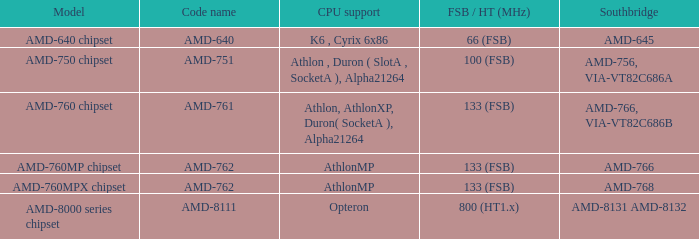Could you parse the entire table? {'header': ['Model', 'Code name', 'CPU support', 'FSB / HT (MHz)', 'Southbridge'], 'rows': [['AMD-640 chipset', 'AMD-640', 'K6 , Cyrix 6x86', '66 (FSB)', 'AMD-645'], ['AMD-750 chipset', 'AMD-751', 'Athlon , Duron ( SlotA , SocketA ), Alpha21264', '100 (FSB)', 'AMD-756, VIA-VT82C686A'], ['AMD-760 chipset', 'AMD-761', 'Athlon, AthlonXP, Duron( SocketA ), Alpha21264', '133 (FSB)', 'AMD-766, VIA-VT82C686B'], ['AMD-760MP chipset', 'AMD-762', 'AthlonMP', '133 (FSB)', 'AMD-766'], ['AMD-760MPX chipset', 'AMD-762', 'AthlonMP', '133 (FSB)', 'AMD-768'], ['AMD-8000 series chipset', 'AMD-8111', 'Opteron', '800 (HT1.x)', 'AMD-8131 AMD-8132']]} What is the code name when the Southbridge shows as amd-766, via-vt82c686b? AMD-761. 